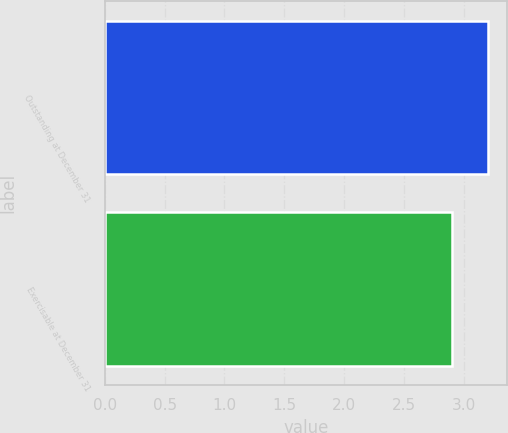Convert chart to OTSL. <chart><loc_0><loc_0><loc_500><loc_500><bar_chart><fcel>Outstanding at December 31<fcel>Exercisable at December 31<nl><fcel>3.2<fcel>2.9<nl></chart> 